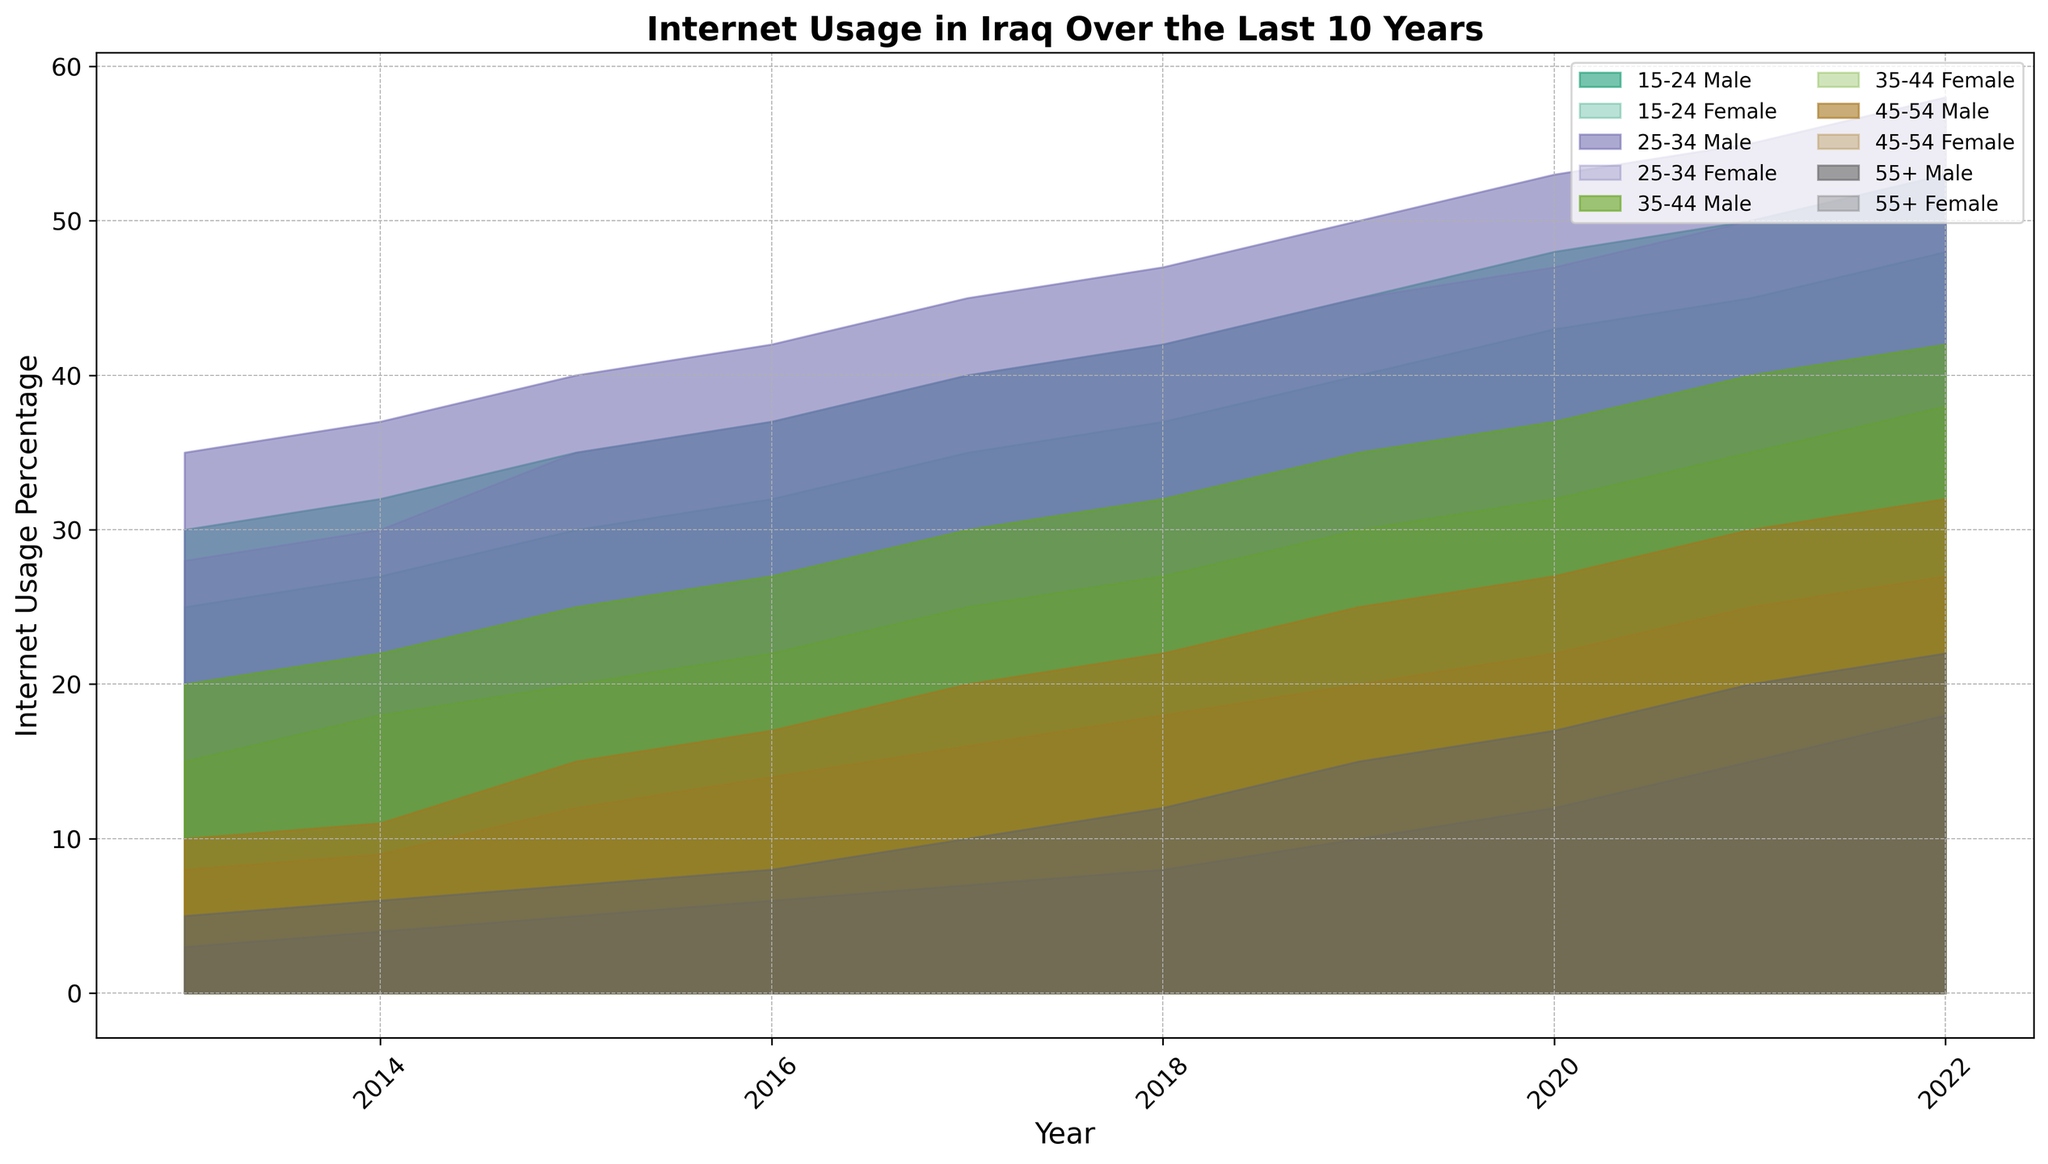What is the overall trend in internet usage for the age group 25-34 over the last 10 years? By observing the area chart, the internet usage percentage for both males and females in the 25-34 age group has been increasing steadily from 2013 to 2022. Both genders have shown significant growth in their internet usage percentages.
Answer: Increasing steadily How does the internet usage of males in the 15-24 age group in 2022 compare to that in 2013? In 2013, the internet usage for males in the 15-24 age group was 30%. In 2022, it increased to 53%. Therefore, there is an increase of 23 percentage points.
Answer: Increased by 23 percentage points Which age group had the smallest increase in internet usage from 2013 to 2022 for females? By looking at the female data across all age groups, the 55+ age group had the smallest increase. For females 55+, the percentage increased from 3% in 2013 to 18% in 2022, which is an increase of 15 percentage points, lower compared to other age groups.
Answer: 55+ age group What is the average internet usage percentage for females in the 25-34 age group over the last 10 years? To calculate the average, sum the internet usage percentages for females in the 25-34 age group for each year and divide by the number of years. (28+30+35+37+40+42+45+47+50+53)/10 = 407/10 = 40.7%
Answer: 40.7% What is the difference in internet usage percentage between males and females in the 35-44 age group in 2016? In 2016, the internet usage percentage for males in the 35-44 age group was 27%, and for females, it was 22%. The difference is 27% - 22% = 5%.
Answer: 5% Which gender had the higher internet usage percentage in the 45-54 age group in 2019? By examining the values for 2019, males in the 45-54 age group had an internet usage percentage of 25%, while females had 20%. Therefore, males had the higher internet usage percentage.
Answer: Males For the year 2020, what is the sum of internet usage percentages for all age groups for males? Add the internet usage percentages for males across all age groups in 2020: 48 + 53 + 37 + 27 + 17 = 182%.
Answer: 182% Between 2017 and 2018, which age group for females saw the largest increase in internet usage? Comparing the internet usage percentages from 2017 to 2018 for females across all age groups, the 15-24 age group saw the largest increase from 35% to 37%, which is an increase of 2 percentage points.
Answer: 15-24 age group How does the internet usage trend for the 55+ age group for both genders compare to younger age groups? The trend for the 55+ age group has shown a steady increase, but the growth rate is slower compared to younger age groups such as 15-24 and 25-34, which have seen more significant increases over the years.
Answer: Steadier and slower increase 